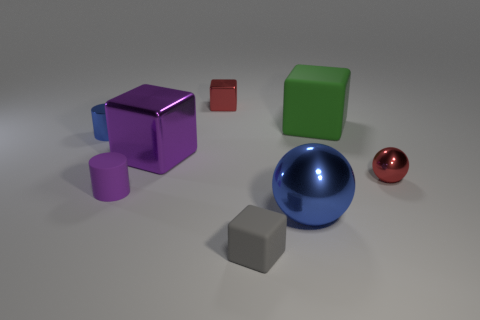What number of shiny objects are on the right side of the red shiny object left of the big green rubber object?
Offer a terse response. 2. How many other things are there of the same size as the green rubber cube?
Provide a short and direct response. 2. Do the tiny metal cube and the small ball have the same color?
Make the answer very short. Yes. Does the tiny red thing that is left of the blue ball have the same shape as the green rubber thing?
Provide a succinct answer. Yes. What number of objects are both behind the purple metal thing and on the left side of the large blue shiny object?
Your answer should be very brief. 2. What is the gray thing made of?
Provide a short and direct response. Rubber. Is there anything else that has the same color as the tiny matte cylinder?
Offer a very short reply. Yes. Does the tiny gray block have the same material as the green object?
Provide a succinct answer. Yes. There is a blue object that is in front of the small red object that is right of the large green cube; what number of balls are left of it?
Your response must be concise. 0. How many gray rubber blocks are there?
Give a very brief answer. 1. 